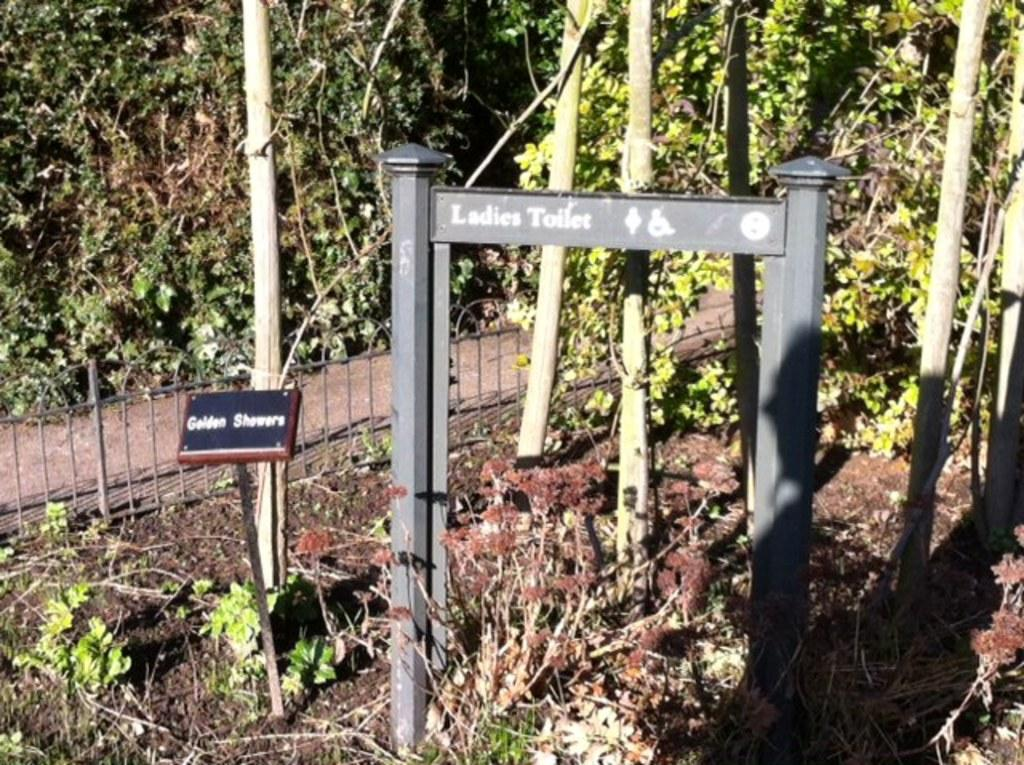What color are the poles in the image? The poles in the image are black colored. What else can be seen in the image besides the poles? There is a board, green and brown trees, a metal pole, the railing, and the ground visible in the image. Can you describe the trees in the image? The trees in the image are green and brown. What is the material of the pole mentioned in the second fact? The board in the image is made of a different material than the poles, but the metal pole is made of metal. What is the surface on which the poles and other objects are placed? The ground is visible in the image, which is the surface on which the poles and other objects are placed. What is the reaction of the trees to the week in the image? There is no mention of a week or any reaction in the image; the trees are simply green and brown. What is the mouth of the metal pole in the image? There is no mouth present in the image, as the metal pole is an inanimate object. 